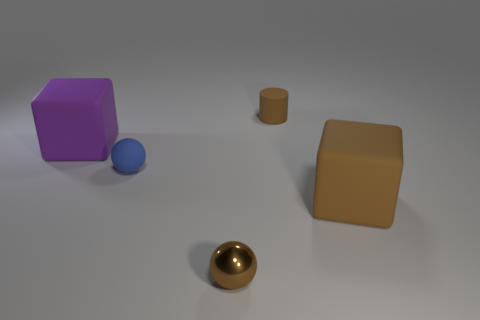The large rubber block that is behind the brown rubber block that is in front of the big rubber cube to the left of the brown metallic sphere is what color?
Provide a short and direct response. Purple. Is there any other thing that is made of the same material as the small brown ball?
Provide a succinct answer. No. What size is the blue rubber object that is the same shape as the metal thing?
Give a very brief answer. Small. Is the number of small metal things that are behind the small shiny object less than the number of large purple cubes left of the cylinder?
Offer a terse response. Yes. The rubber object that is behind the small blue matte ball and on the right side of the small brown ball has what shape?
Make the answer very short. Cylinder. There is a blue sphere that is the same material as the tiny cylinder; what is its size?
Your answer should be very brief. Small. Does the matte cylinder have the same color as the matte block right of the brown ball?
Provide a short and direct response. Yes. What material is the thing that is both right of the blue sphere and to the left of the cylinder?
Keep it short and to the point. Metal. What is the size of the matte block that is the same color as the shiny sphere?
Your answer should be compact. Large. There is a small object to the left of the tiny metal ball; does it have the same shape as the large thing on the left side of the matte ball?
Your answer should be very brief. No. 